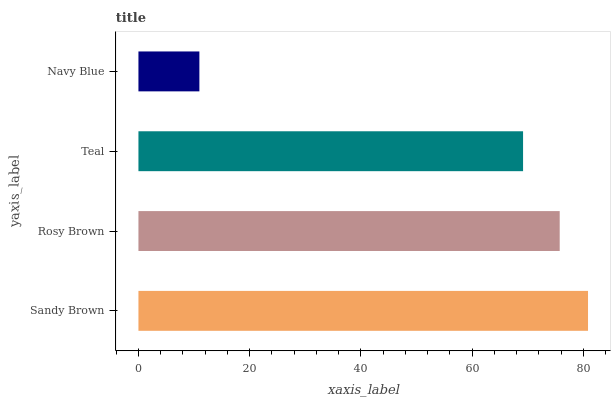Is Navy Blue the minimum?
Answer yes or no. Yes. Is Sandy Brown the maximum?
Answer yes or no. Yes. Is Rosy Brown the minimum?
Answer yes or no. No. Is Rosy Brown the maximum?
Answer yes or no. No. Is Sandy Brown greater than Rosy Brown?
Answer yes or no. Yes. Is Rosy Brown less than Sandy Brown?
Answer yes or no. Yes. Is Rosy Brown greater than Sandy Brown?
Answer yes or no. No. Is Sandy Brown less than Rosy Brown?
Answer yes or no. No. Is Rosy Brown the high median?
Answer yes or no. Yes. Is Teal the low median?
Answer yes or no. Yes. Is Navy Blue the high median?
Answer yes or no. No. Is Sandy Brown the low median?
Answer yes or no. No. 